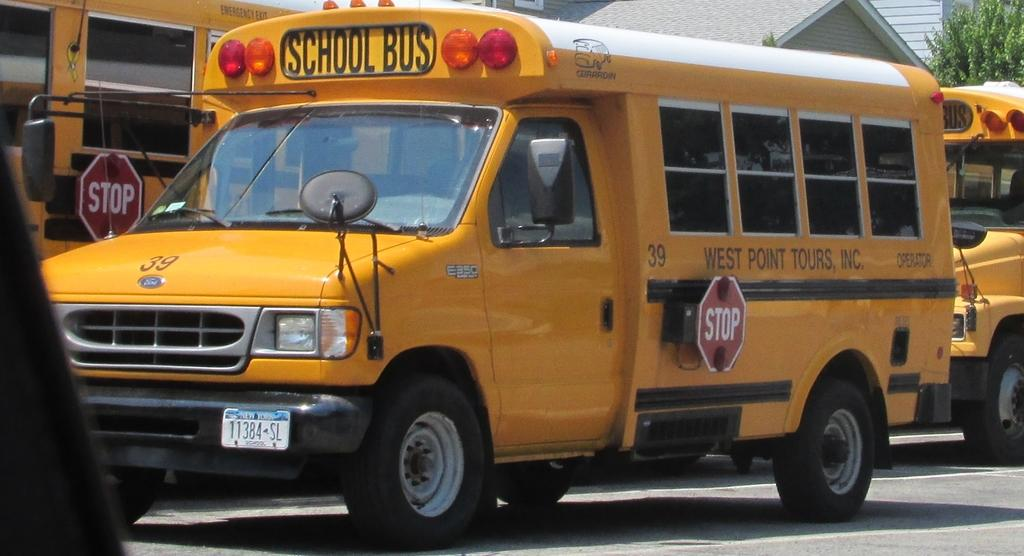What can be seen on the road in the image? There are vehicles on the road in the image. What is written or displayed on the vehicles? Text is visible on the vehicles. What structures are located at the top of the image? There are buildings at the top of the image. What type of plant is present at the top of the image? There is a tree at the top of the image. Can you tell me what type of trousers the carpenter is wearing in the image? There is no carpenter or trousers present in the image. How many ducks are visible in the image? There are no ducks present in the image. 